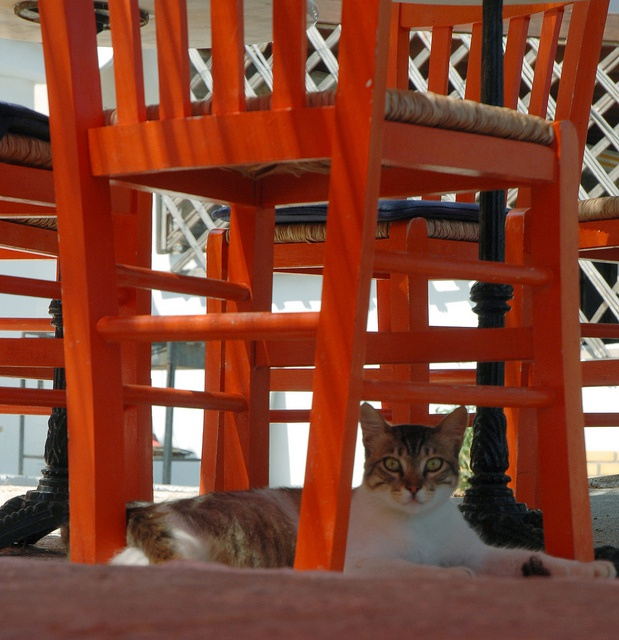Describe the objects in this image and their specific colors. I can see chair in tan, brown, maroon, and red tones, chair in tan, maroon, black, and white tones, cat in tan, gray, maroon, and black tones, chair in tan, maroon, black, and lightgray tones, and chair in tan and maroon tones in this image. 